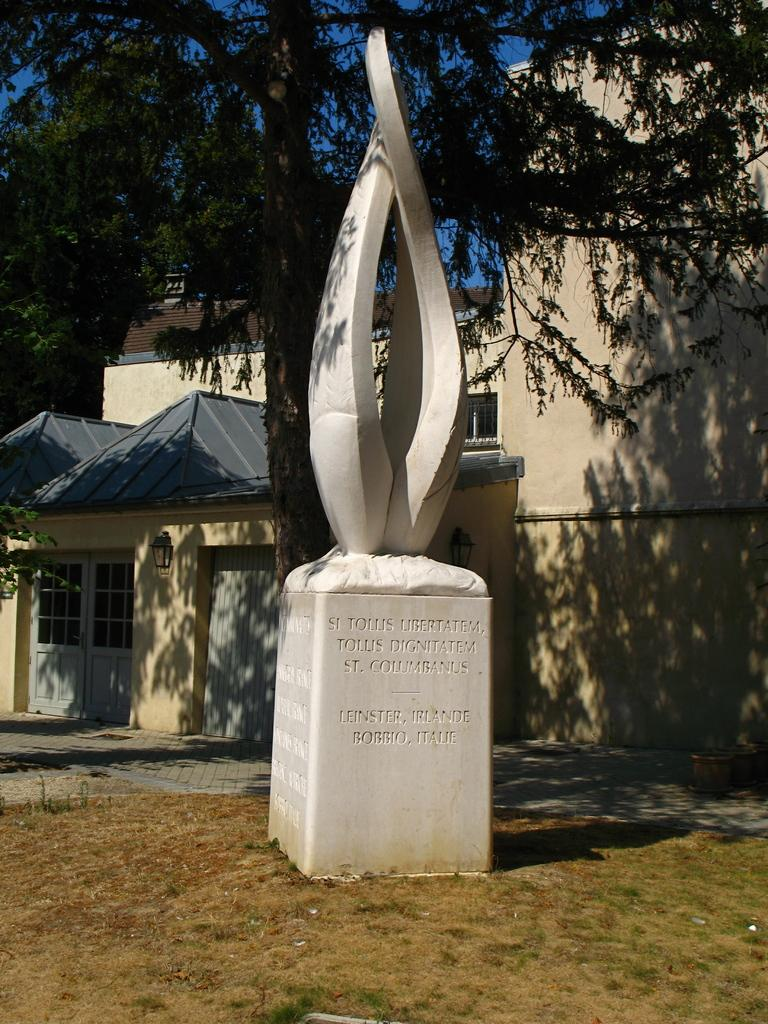What is the main subject of the image? There is a sculpture on a block in the image. What is written or depicted on the block? There is text on the block. What type of structures can be seen in the background? There are buildings visible in the image. What type of natural environment is present in the image? There is grass and a tree in the image. What type of industry is depicted in the image? There is no industry depicted in the image; it features a sculpture on a block with text, buildings in the background, grass, and a tree. Can you describe the driving conditions in the image? There is no driving or vehicles present in the image; it focuses on the sculpture, text, buildings, grass, and tree. 